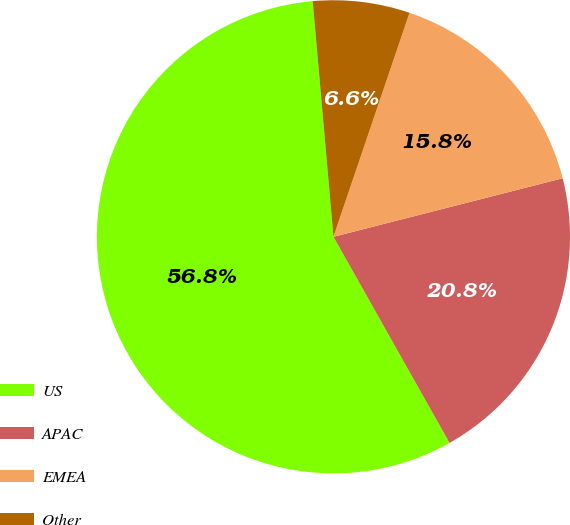<chart> <loc_0><loc_0><loc_500><loc_500><pie_chart><fcel>US<fcel>APAC<fcel>EMEA<fcel>Other<nl><fcel>56.77%<fcel>20.82%<fcel>15.81%<fcel>6.61%<nl></chart> 